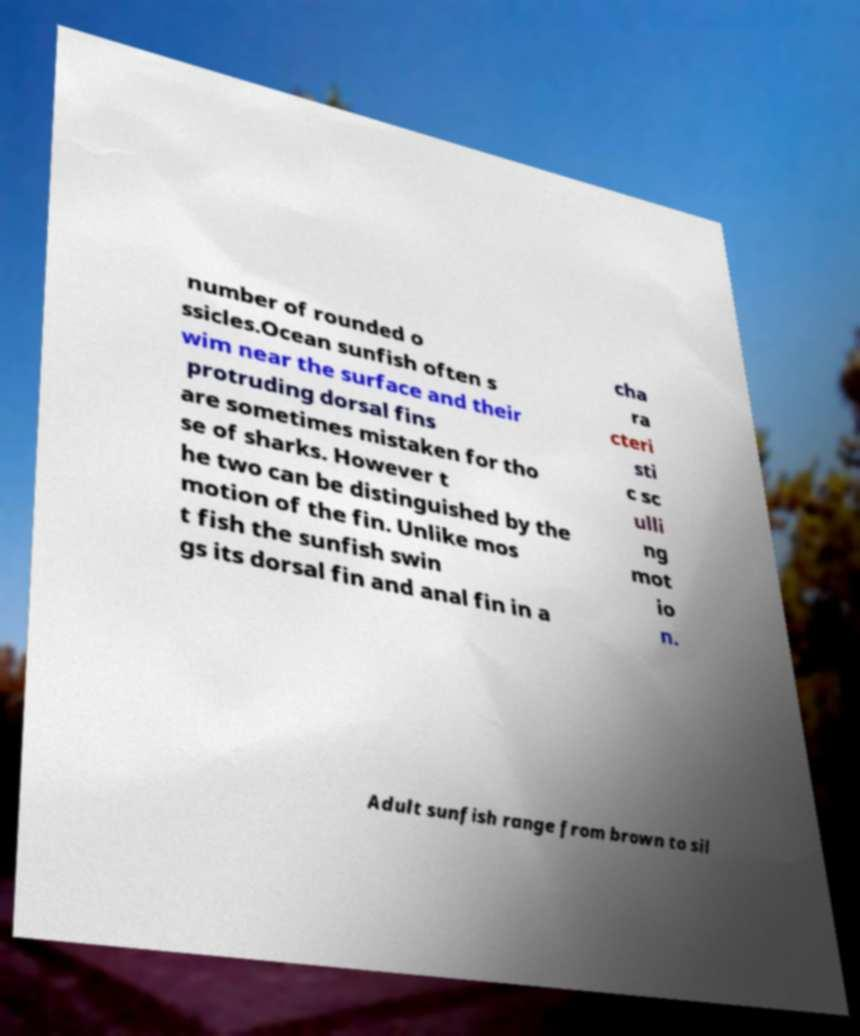For documentation purposes, I need the text within this image transcribed. Could you provide that? number of rounded o ssicles.Ocean sunfish often s wim near the surface and their protruding dorsal fins are sometimes mistaken for tho se of sharks. However t he two can be distinguished by the motion of the fin. Unlike mos t fish the sunfish swin gs its dorsal fin and anal fin in a cha ra cteri sti c sc ulli ng mot io n. Adult sunfish range from brown to sil 